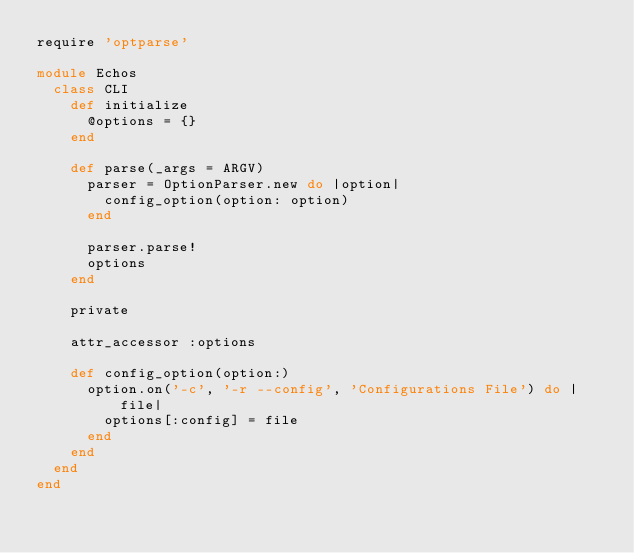Convert code to text. <code><loc_0><loc_0><loc_500><loc_500><_Ruby_>require 'optparse'

module Echos
  class CLI
    def initialize
      @options = {}
    end

    def parse(_args = ARGV)
      parser = OptionParser.new do |option|
        config_option(option: option)
      end

      parser.parse!
      options
    end

    private

    attr_accessor :options

    def config_option(option:)
      option.on('-c', '-r --config', 'Configurations File') do |file|
        options[:config] = file
      end
    end
  end
end
</code> 